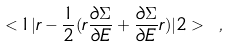Convert formula to latex. <formula><loc_0><loc_0><loc_500><loc_500>< 1 | r - \frac { 1 } { 2 } ( r \frac { \partial \Sigma } { \partial E } + \frac { \partial \Sigma } { \partial E } r ) | 2 > \ ,</formula> 